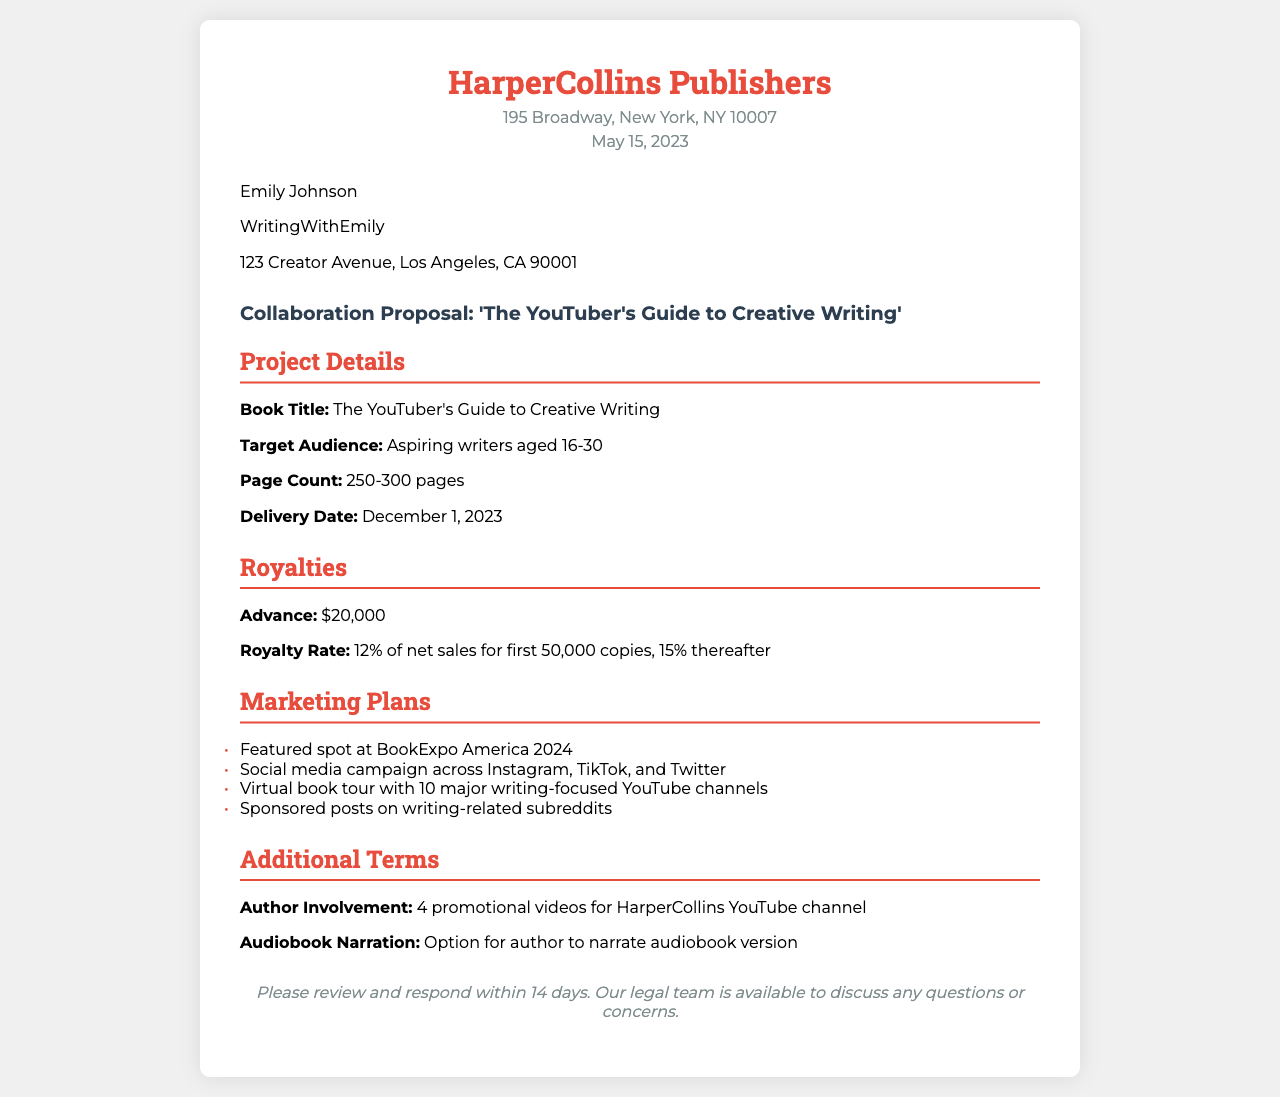What is the book title? The book title is explicitly stated in the document under the Project Details section.
Answer: The YouTuber's Guide to Creative Writing What is the advance amount offered? The advance amount is mentioned under the Royalties section of the document.
Answer: $20,000 Who is the recipient of this collaboration proposal? The recipient's name is provided at the beginning of the document.
Answer: Emily Johnson What is the royalty rate for the first 50,000 copies? The royalty rate is listed in the Royalties section and specifies the rate for the initial sales.
Answer: 12% of net sales When is the delivery date for the book? The delivery date is outlined in the Project Details section of the document.
Answer: December 1, 2023 What is one marketing plan mentioned in the document? The marketing plans are enumerated in the Marketing Plans section and indicate specific promotional strategies.
Answer: Featured spot at BookExpo America 2024 How many promotional videos is the author expected to create? The number of promotional videos is detailed in the Additional Terms section of the document.
Answer: 4 promotional videos What is the page count of the book? The page count is mentioned in the Project Details section.
Answer: 250-300 pages 